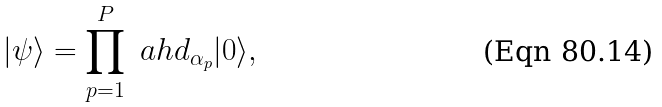<formula> <loc_0><loc_0><loc_500><loc_500>| \psi \rangle = \prod _ { p = 1 } ^ { P } \ a h d _ { \alpha _ { p } } | 0 \rangle ,</formula> 